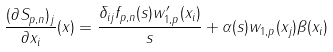Convert formula to latex. <formula><loc_0><loc_0><loc_500><loc_500>\frac { ( \partial S _ { p , n } ) _ { j } } { \partial x _ { i } } ( x ) = \frac { \delta _ { i j } f _ { p , n } ( s ) w _ { 1 , p } ^ { \prime } ( x _ { i } ) } { s } + \alpha ( s ) w _ { 1 , p } ( x _ { j } ) \beta ( x _ { i } )</formula> 